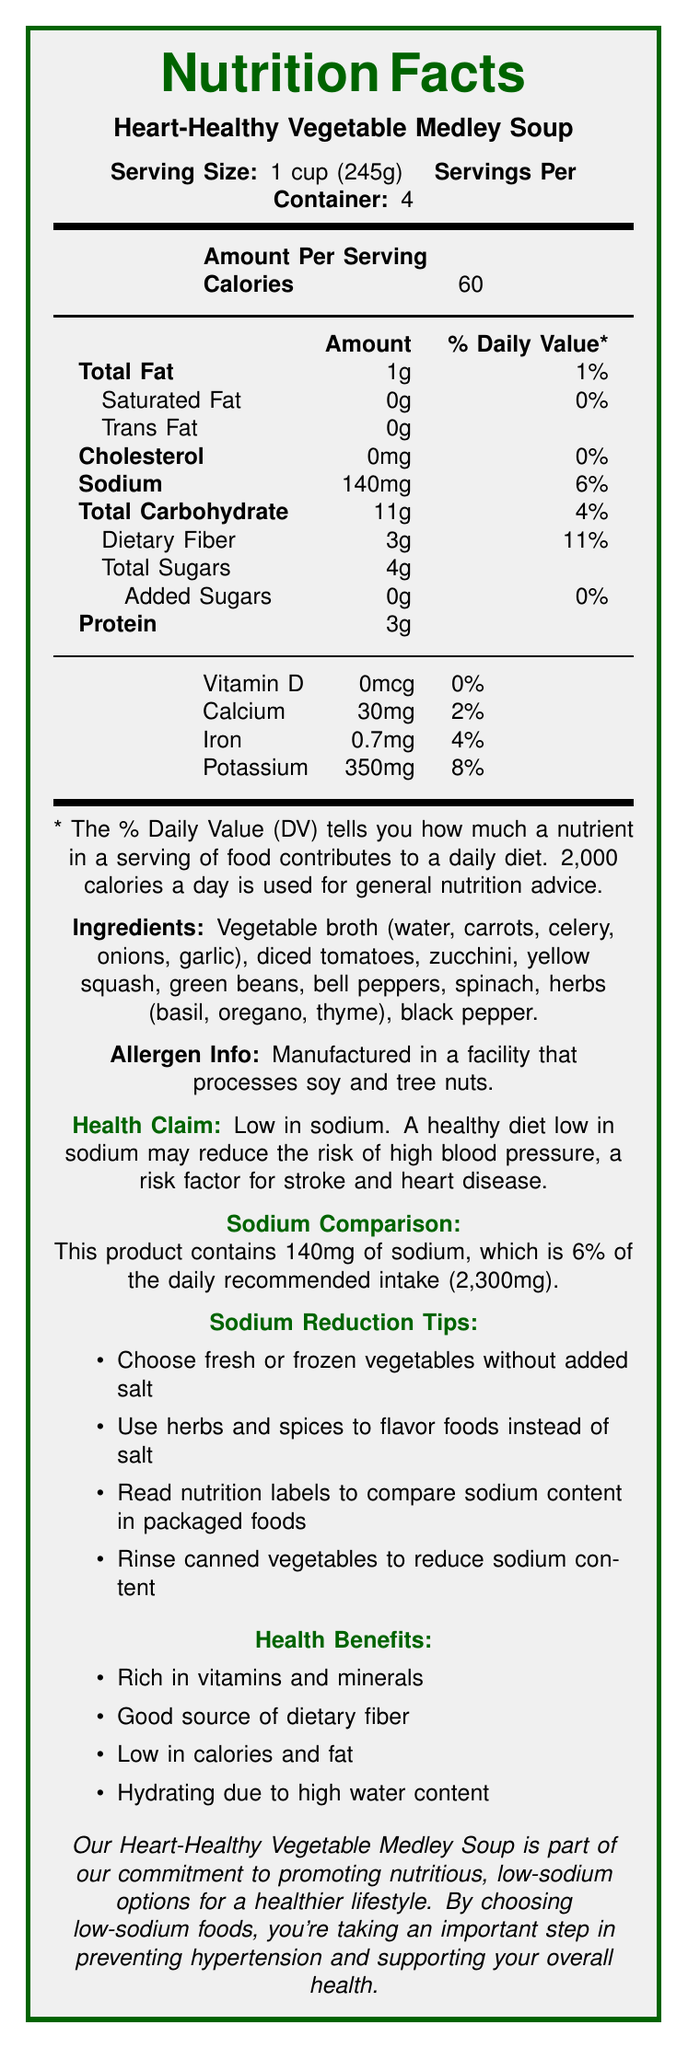what is the serving size of the Heart-Healthy Vegetable Medley Soup? The serving size is clearly listed as "1 cup (245g)" in the nutrition facts section.
Answer: 1 cup (245g) how many servings are there per container of the soup? The document states that there are "4" servings per container.
Answer: 4 how many calories does one serving of the soup contain? The document specifies that each serving contains "60" calories.
Answer: 60 how many grams of dietary fiber are in one serving? The dietary fiber content per serving is listed as "3g".
Answer: 3g is this product low in sodium, based on its sodium content? The sodium content is "140mg" per serving, which is 6% of the daily recommended intake, and the health claim indicates it is low in sodium.
Answer: Yes what percentage of the daily value for sodium is provided by one serving? The sodium content per serving contributes to "6%" of the daily recommended intake.
Answer: 6% what are the main ingredients in the soup? The ingredients are listed as: Vegetable broth (water, carrots, celery, onions, garlic), diced tomatoes, zucchini, yellow squash, green beans, bell peppers, spinach, herbs (basil, oregano, thyme), black pepper.
Answer: Vegetable broth, diced tomatoes, zucchini, yellow squash, green beans, bell peppers, spinach, herbs, black pepper which vitamin or mineral has the highest daily value percentage in the soup? The potassium content per serving provides "8%" of the daily value, which is the highest among the listed vitamins and minerals.
Answer: Potassium which of the following is true about the soup's fat content?
A. Contains 1g of saturated fat
B. Contains 0g of trans fat and 1g of total fat
C. Contains 140mg of trans fat
D. Contains 30mg of total fat The nutrition facts state that the soup contains "0g trans fat" and "1g total fat".
Answer: B what percentage of the daily recommended intake of iron does one serving of the soup provide? The document lists the iron content as "0.7mg", contributing to "4%" of the daily recommended intake.
Answer: 4% is the soup manufactured in a facility that processes soy and tree nuts? The allergen information states that the soup is "Manufactured in a facility that processes soy and tree nuts."
Answer: Yes name one health benefit of consuming this soup. The health benefits mention that the soup is a "Good source of dietary fiber".
Answer: Good source of dietary fiber what is the main idea of this document? The document includes detailed nutrition facts, ingredients, health claims, and messages from the organization, all centered around promoting the soup's healthfulness and low sodium content.
Answer: The document provides nutritional information about the Heart-Healthy Vegetable Medley Soup, emphasizing its low sodium content and health benefits, and includes sodium reduction tips and an organization message promoting healthy lifestyles. what is the total sugar content in one serving of the soup? The total sugar content per serving is listed as "4g".
Answer: 4g if a person consumed the whole container of soup, how much sodium would they intake compared to the daily recommended intake? A. 12% B. 18% C. 24% D. 30% One serving contains 140mg of sodium (6%), and the container has 4 servings, so total sodium intake is 140mg * 4 = 560mg, which is 24% of the daily recommended intake.
Answer: C is the document clear about the amount of added sugars in the soup? The document specifies that the soup contains "0g" of added sugars.
Answer: Yes what is the potassium content in milligrams per serving? The potassium content is clearly listed as "350mg" per serving.
Answer: 350mg what advice is given for reducing sodium intake when consuming vegetables? These sodium reduction tips are included in the document.
Answer: Choose fresh or frozen vegetables without added salt. Use herbs and spices to flavor foods instead of salt. Read nutrition labels to compare sodium content in packaged foods. Rinse canned vegetables to reduce sodium content. is the soup high in calories? The soup contains "60" calories per serving, which is low.
Answer: No what is the recommended daily intake of sodium according to the document? The document states that the daily recommended intake of sodium is "2300mg".
Answer: 2300mg what is the amount of dietary fiber provided if a person consumes two servings of the soup? One serving contains "3g" of dietary fiber, so two servings will contain "3g * 2 = 6g".
Answer: 6g 